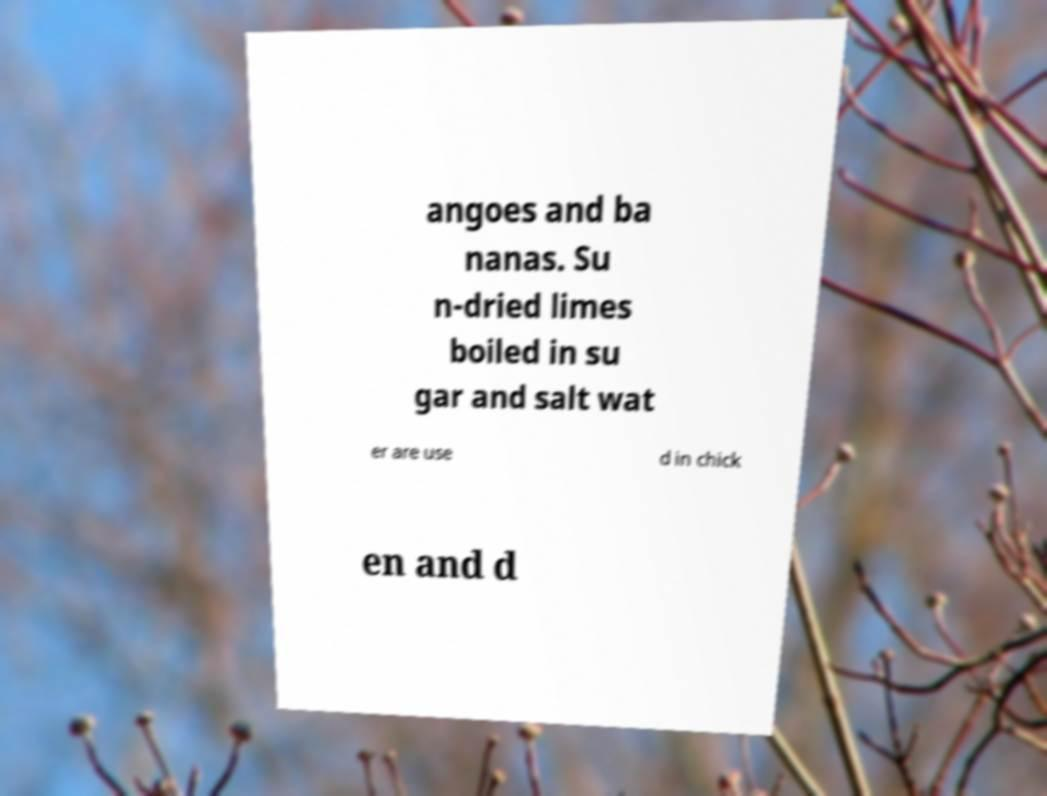Can you read and provide the text displayed in the image?This photo seems to have some interesting text. Can you extract and type it out for me? angoes and ba nanas. Su n-dried limes boiled in su gar and salt wat er are use d in chick en and d 